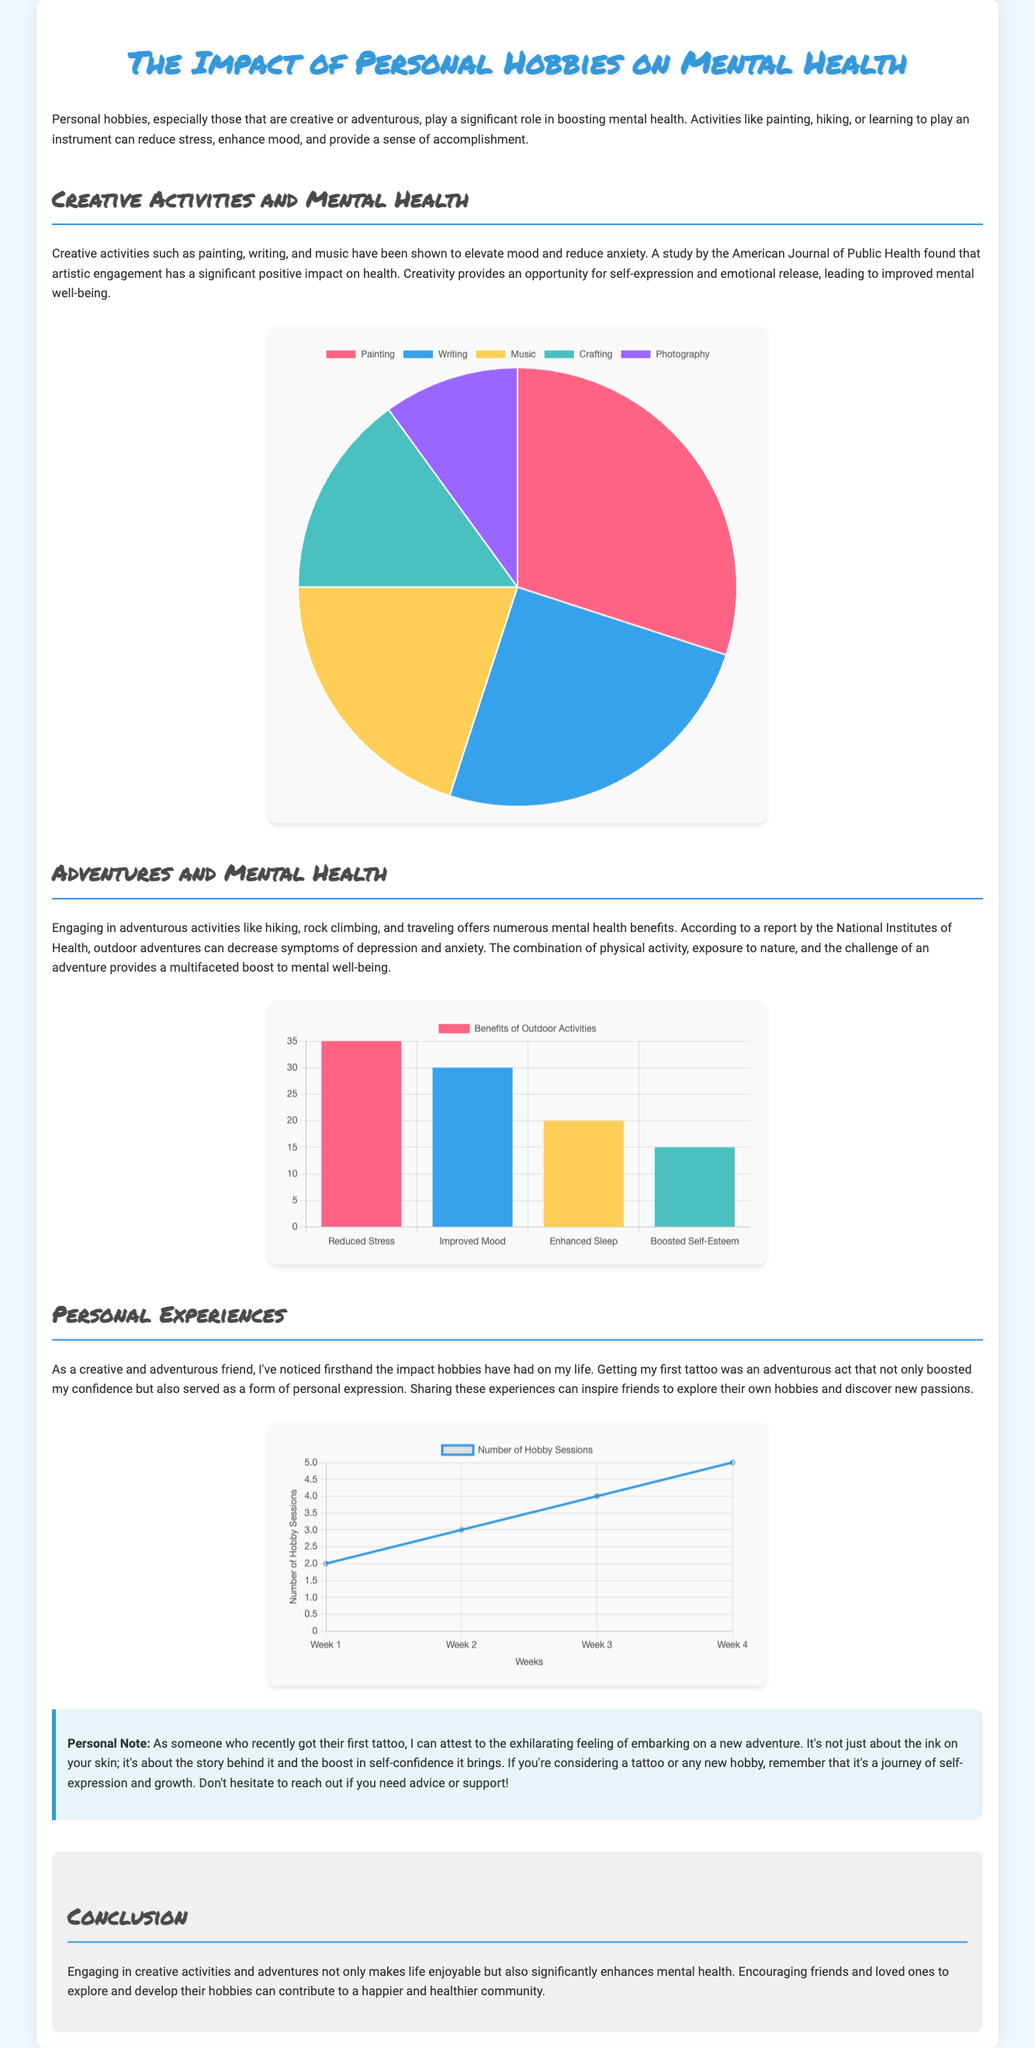What are the five types of creative activities mentioned? The document lists painting, writing, music, crafting, and photography as the five types of creative activities.
Answer: Painting, writing, music, crafting, photography What percentage represents music in the creative activities chart? In the pie chart, the segment for music is labeled with a value of 20%.
Answer: 20% What is the most significant benefit of outdoor activities according to the outdoor benefits chart? The bar chart indicates that reduced stress is the most significant benefit of outdoor activities, with a value of 35%.
Answer: Reduced Stress How many hobby sessions were recorded in Week 4? The line chart shows that there were 5 hobby sessions in Week 4.
Answer: 5 What is the overall theme of the infographic? The document's theme revolves around the impact of personal hobbies, particularly creative and adventurous activities, on mental health.
Answer: The impact of personal hobbies on mental health How many types of outdoor activity benefits are listed in the chart? The outdoor benefits chart presents four distinct benefits of outdoor activities.
Answer: Four What was the author's personal experience mentioned in the document? The author shares that getting their first tattoo was an adventurous act leading to boosted confidence and personal expression.
Answer: Getting a tattoo What type of data visualization is used to represent the types of creative activities? The types of creative activities are represented using a pie chart.
Answer: Pie chart 